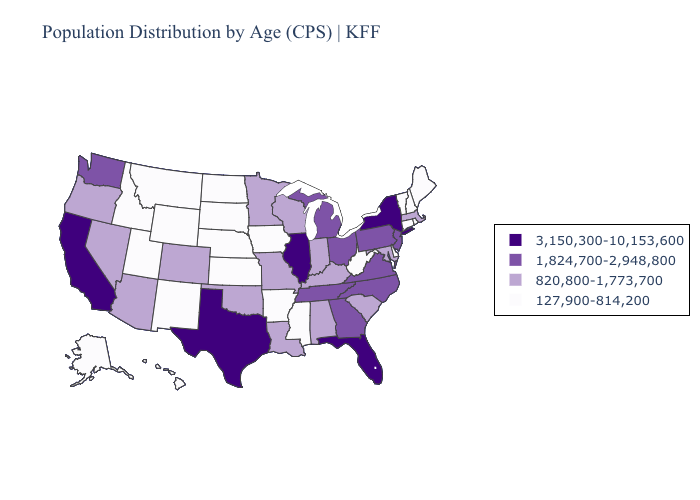Name the states that have a value in the range 1,824,700-2,948,800?
Keep it brief. Georgia, Michigan, New Jersey, North Carolina, Ohio, Pennsylvania, Tennessee, Virginia, Washington. Name the states that have a value in the range 3,150,300-10,153,600?
Answer briefly. California, Florida, Illinois, New York, Texas. Does Wisconsin have a lower value than Oklahoma?
Keep it brief. No. Name the states that have a value in the range 127,900-814,200?
Give a very brief answer. Alaska, Arkansas, Connecticut, Delaware, Hawaii, Idaho, Iowa, Kansas, Maine, Mississippi, Montana, Nebraska, New Hampshire, New Mexico, North Dakota, Rhode Island, South Dakota, Utah, Vermont, West Virginia, Wyoming. What is the value of Massachusetts?
Concise answer only. 820,800-1,773,700. Name the states that have a value in the range 127,900-814,200?
Be succinct. Alaska, Arkansas, Connecticut, Delaware, Hawaii, Idaho, Iowa, Kansas, Maine, Mississippi, Montana, Nebraska, New Hampshire, New Mexico, North Dakota, Rhode Island, South Dakota, Utah, Vermont, West Virginia, Wyoming. Does Maryland have the same value as Oklahoma?
Concise answer only. Yes. Name the states that have a value in the range 127,900-814,200?
Give a very brief answer. Alaska, Arkansas, Connecticut, Delaware, Hawaii, Idaho, Iowa, Kansas, Maine, Mississippi, Montana, Nebraska, New Hampshire, New Mexico, North Dakota, Rhode Island, South Dakota, Utah, Vermont, West Virginia, Wyoming. What is the value of Oregon?
Concise answer only. 820,800-1,773,700. Does Massachusetts have a lower value than Tennessee?
Keep it brief. Yes. Among the states that border Iowa , which have the lowest value?
Keep it brief. Nebraska, South Dakota. Name the states that have a value in the range 3,150,300-10,153,600?
Short answer required. California, Florida, Illinois, New York, Texas. What is the highest value in the USA?
Keep it brief. 3,150,300-10,153,600. What is the lowest value in the USA?
Write a very short answer. 127,900-814,200. What is the lowest value in states that border Massachusetts?
Quick response, please. 127,900-814,200. 